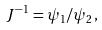Convert formula to latex. <formula><loc_0><loc_0><loc_500><loc_500>J ^ { - 1 } = \psi _ { 1 } / \psi _ { 2 } ,</formula> 